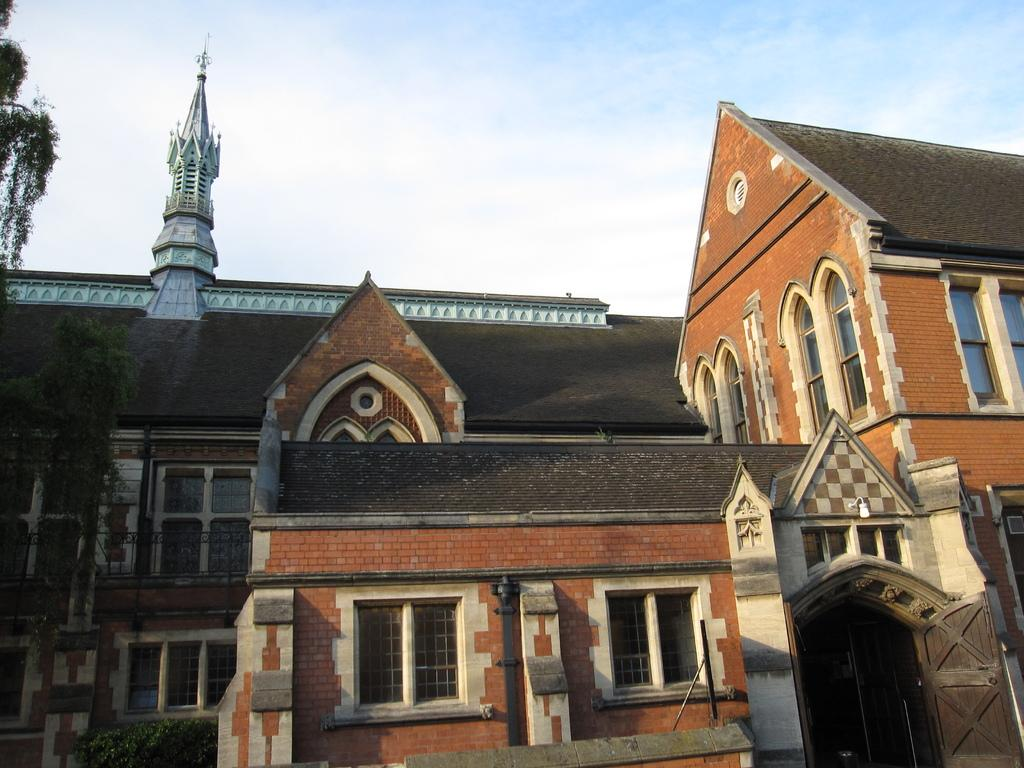What type of structures can be seen in the image? There are buildings in the image. What else is present in the image besides the buildings? There are plants, a grille, and windows visible in the image. What can be seen in the background of the image? The sky with clouds is visible in the background of the image. What grade: What grade did the beggar receive in the afternoon in the image? There is no beggar or grade present in the image. 